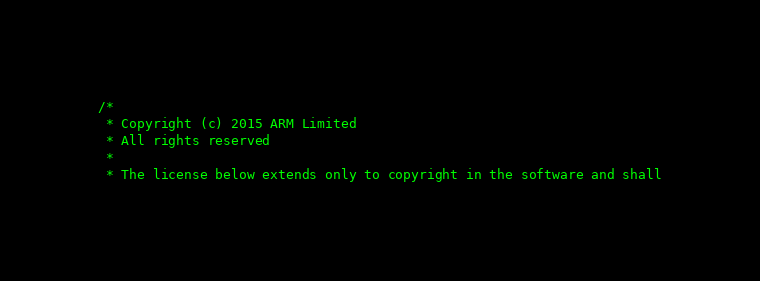Convert code to text. <code><loc_0><loc_0><loc_500><loc_500><_C++_>/*
 * Copyright (c) 2015 ARM Limited
 * All rights reserved
 *
 * The license below extends only to copyright in the software and shall</code> 